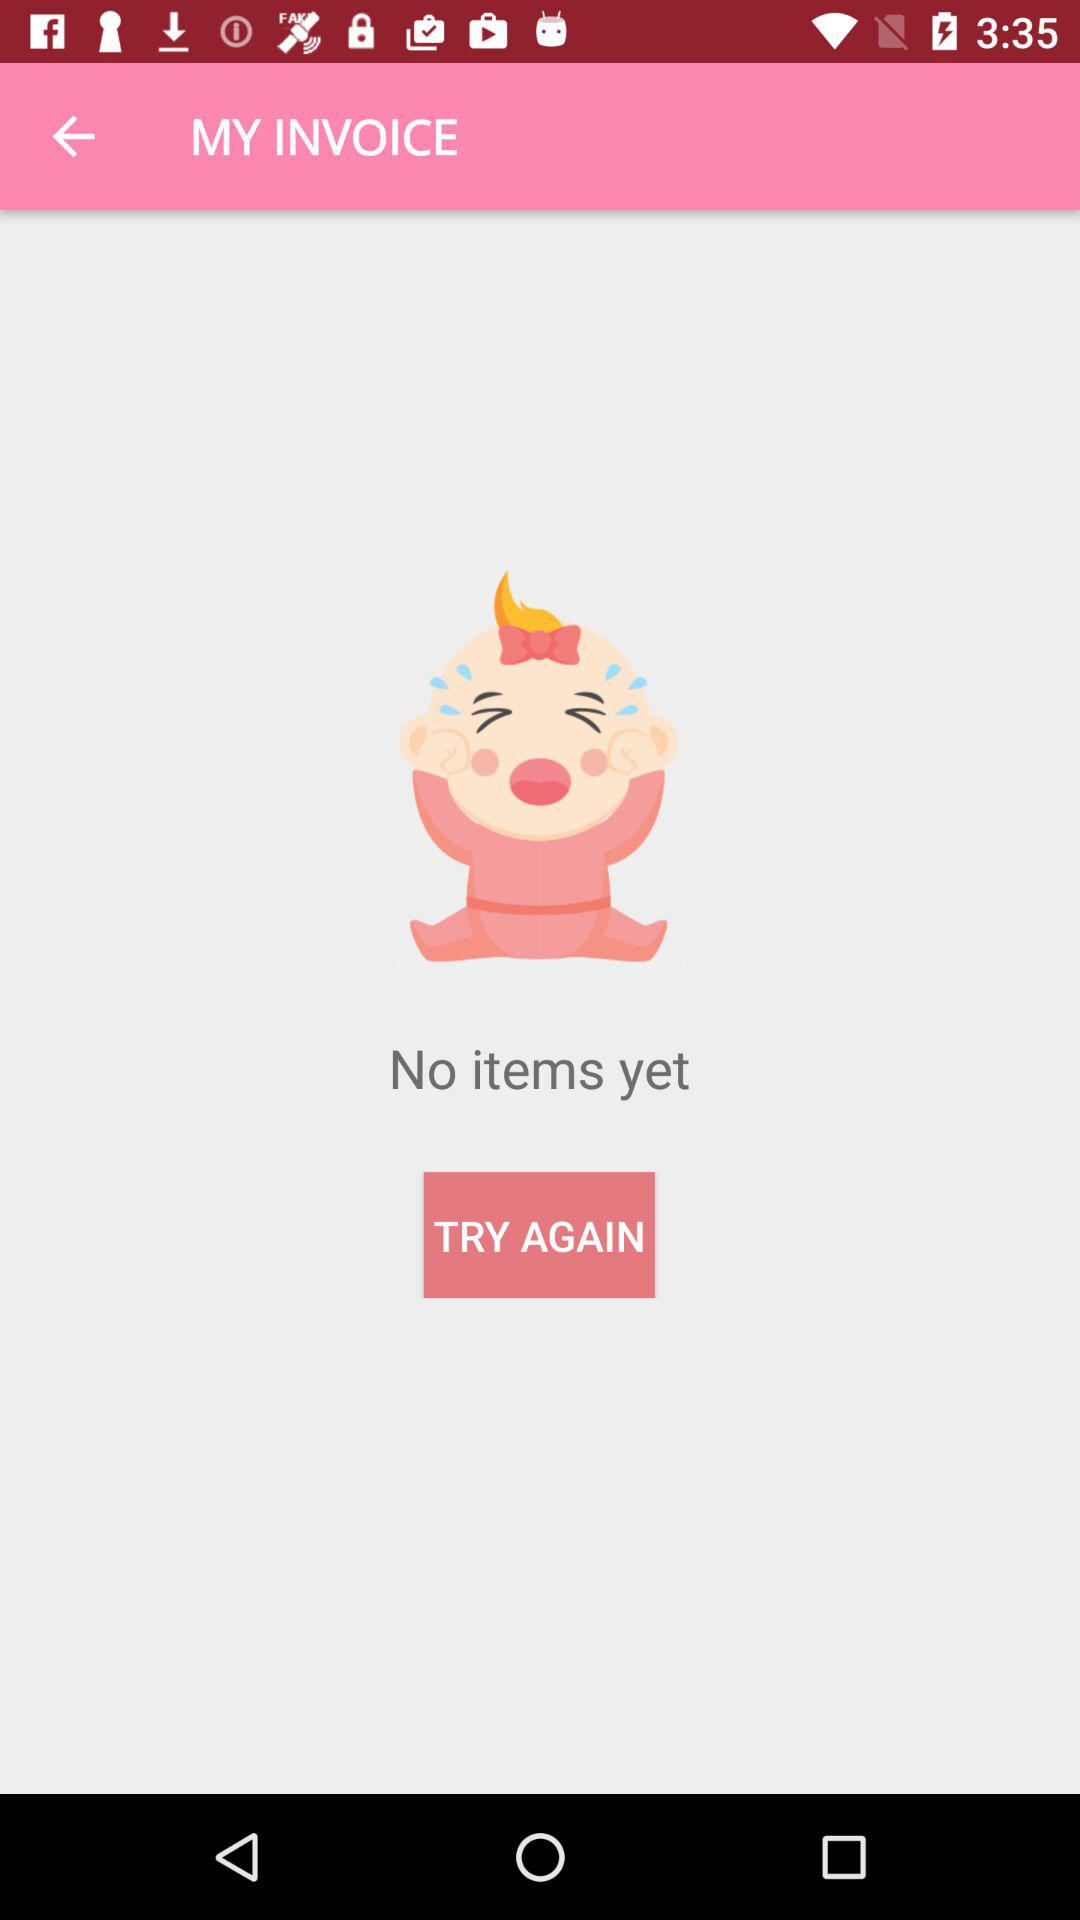How many items are there? There are no items. 